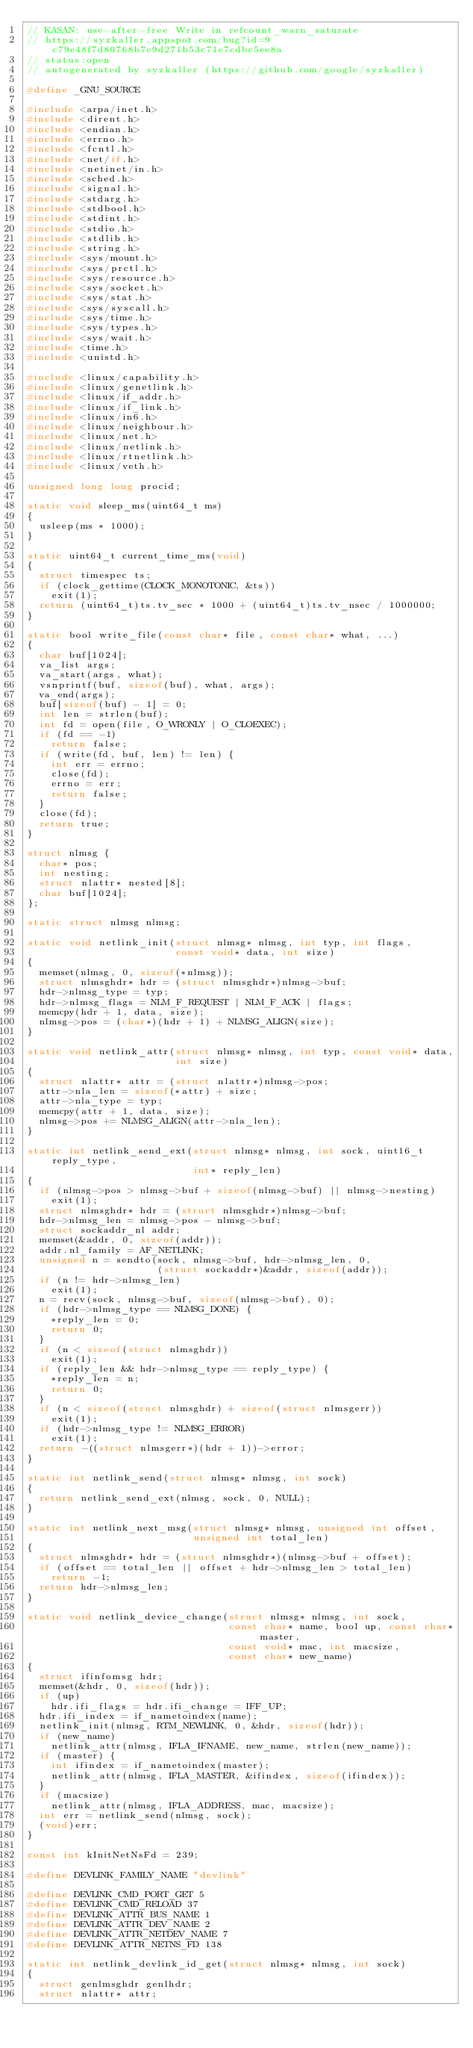<code> <loc_0><loc_0><loc_500><loc_500><_C_>// KASAN: use-after-free Write in refcount_warn_saturate
// https://syzkaller.appspot.com/bug?id=9c79e48f7d80768b7e9d271b53c71e7cdbc5ee8a
// status:open
// autogenerated by syzkaller (https://github.com/google/syzkaller)

#define _GNU_SOURCE

#include <arpa/inet.h>
#include <dirent.h>
#include <endian.h>
#include <errno.h>
#include <fcntl.h>
#include <net/if.h>
#include <netinet/in.h>
#include <sched.h>
#include <signal.h>
#include <stdarg.h>
#include <stdbool.h>
#include <stdint.h>
#include <stdio.h>
#include <stdlib.h>
#include <string.h>
#include <sys/mount.h>
#include <sys/prctl.h>
#include <sys/resource.h>
#include <sys/socket.h>
#include <sys/stat.h>
#include <sys/syscall.h>
#include <sys/time.h>
#include <sys/types.h>
#include <sys/wait.h>
#include <time.h>
#include <unistd.h>

#include <linux/capability.h>
#include <linux/genetlink.h>
#include <linux/if_addr.h>
#include <linux/if_link.h>
#include <linux/in6.h>
#include <linux/neighbour.h>
#include <linux/net.h>
#include <linux/netlink.h>
#include <linux/rtnetlink.h>
#include <linux/veth.h>

unsigned long long procid;

static void sleep_ms(uint64_t ms)
{
  usleep(ms * 1000);
}

static uint64_t current_time_ms(void)
{
  struct timespec ts;
  if (clock_gettime(CLOCK_MONOTONIC, &ts))
    exit(1);
  return (uint64_t)ts.tv_sec * 1000 + (uint64_t)ts.tv_nsec / 1000000;
}

static bool write_file(const char* file, const char* what, ...)
{
  char buf[1024];
  va_list args;
  va_start(args, what);
  vsnprintf(buf, sizeof(buf), what, args);
  va_end(args);
  buf[sizeof(buf) - 1] = 0;
  int len = strlen(buf);
  int fd = open(file, O_WRONLY | O_CLOEXEC);
  if (fd == -1)
    return false;
  if (write(fd, buf, len) != len) {
    int err = errno;
    close(fd);
    errno = err;
    return false;
  }
  close(fd);
  return true;
}

struct nlmsg {
  char* pos;
  int nesting;
  struct nlattr* nested[8];
  char buf[1024];
};

static struct nlmsg nlmsg;

static void netlink_init(struct nlmsg* nlmsg, int typ, int flags,
                         const void* data, int size)
{
  memset(nlmsg, 0, sizeof(*nlmsg));
  struct nlmsghdr* hdr = (struct nlmsghdr*)nlmsg->buf;
  hdr->nlmsg_type = typ;
  hdr->nlmsg_flags = NLM_F_REQUEST | NLM_F_ACK | flags;
  memcpy(hdr + 1, data, size);
  nlmsg->pos = (char*)(hdr + 1) + NLMSG_ALIGN(size);
}

static void netlink_attr(struct nlmsg* nlmsg, int typ, const void* data,
                         int size)
{
  struct nlattr* attr = (struct nlattr*)nlmsg->pos;
  attr->nla_len = sizeof(*attr) + size;
  attr->nla_type = typ;
  memcpy(attr + 1, data, size);
  nlmsg->pos += NLMSG_ALIGN(attr->nla_len);
}

static int netlink_send_ext(struct nlmsg* nlmsg, int sock, uint16_t reply_type,
                            int* reply_len)
{
  if (nlmsg->pos > nlmsg->buf + sizeof(nlmsg->buf) || nlmsg->nesting)
    exit(1);
  struct nlmsghdr* hdr = (struct nlmsghdr*)nlmsg->buf;
  hdr->nlmsg_len = nlmsg->pos - nlmsg->buf;
  struct sockaddr_nl addr;
  memset(&addr, 0, sizeof(addr));
  addr.nl_family = AF_NETLINK;
  unsigned n = sendto(sock, nlmsg->buf, hdr->nlmsg_len, 0,
                      (struct sockaddr*)&addr, sizeof(addr));
  if (n != hdr->nlmsg_len)
    exit(1);
  n = recv(sock, nlmsg->buf, sizeof(nlmsg->buf), 0);
  if (hdr->nlmsg_type == NLMSG_DONE) {
    *reply_len = 0;
    return 0;
  }
  if (n < sizeof(struct nlmsghdr))
    exit(1);
  if (reply_len && hdr->nlmsg_type == reply_type) {
    *reply_len = n;
    return 0;
  }
  if (n < sizeof(struct nlmsghdr) + sizeof(struct nlmsgerr))
    exit(1);
  if (hdr->nlmsg_type != NLMSG_ERROR)
    exit(1);
  return -((struct nlmsgerr*)(hdr + 1))->error;
}

static int netlink_send(struct nlmsg* nlmsg, int sock)
{
  return netlink_send_ext(nlmsg, sock, 0, NULL);
}

static int netlink_next_msg(struct nlmsg* nlmsg, unsigned int offset,
                            unsigned int total_len)
{
  struct nlmsghdr* hdr = (struct nlmsghdr*)(nlmsg->buf + offset);
  if (offset == total_len || offset + hdr->nlmsg_len > total_len)
    return -1;
  return hdr->nlmsg_len;
}

static void netlink_device_change(struct nlmsg* nlmsg, int sock,
                                  const char* name, bool up, const char* master,
                                  const void* mac, int macsize,
                                  const char* new_name)
{
  struct ifinfomsg hdr;
  memset(&hdr, 0, sizeof(hdr));
  if (up)
    hdr.ifi_flags = hdr.ifi_change = IFF_UP;
  hdr.ifi_index = if_nametoindex(name);
  netlink_init(nlmsg, RTM_NEWLINK, 0, &hdr, sizeof(hdr));
  if (new_name)
    netlink_attr(nlmsg, IFLA_IFNAME, new_name, strlen(new_name));
  if (master) {
    int ifindex = if_nametoindex(master);
    netlink_attr(nlmsg, IFLA_MASTER, &ifindex, sizeof(ifindex));
  }
  if (macsize)
    netlink_attr(nlmsg, IFLA_ADDRESS, mac, macsize);
  int err = netlink_send(nlmsg, sock);
  (void)err;
}

const int kInitNetNsFd = 239;

#define DEVLINK_FAMILY_NAME "devlink"

#define DEVLINK_CMD_PORT_GET 5
#define DEVLINK_CMD_RELOAD 37
#define DEVLINK_ATTR_BUS_NAME 1
#define DEVLINK_ATTR_DEV_NAME 2
#define DEVLINK_ATTR_NETDEV_NAME 7
#define DEVLINK_ATTR_NETNS_FD 138

static int netlink_devlink_id_get(struct nlmsg* nlmsg, int sock)
{
  struct genlmsghdr genlhdr;
  struct nlattr* attr;</code> 